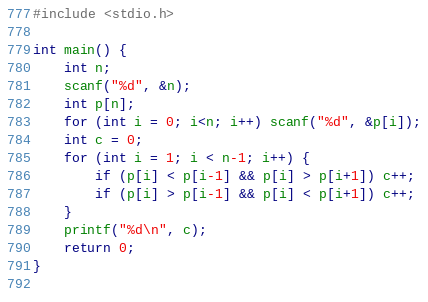<code> <loc_0><loc_0><loc_500><loc_500><_C_>#include <stdio.h>

int main() {
	int n;
	scanf("%d", &n);
	int p[n];
	for (int i = 0; i<n; i++) scanf("%d", &p[i]);
	int c = 0;
	for (int i = 1; i < n-1; i++) {
		if (p[i] < p[i-1] && p[i] > p[i+1]) c++;
		if (p[i] > p[i-1] && p[i] < p[i+1]) c++;
	} 
	printf("%d\n", c);
	return 0;
}
	
</code> 